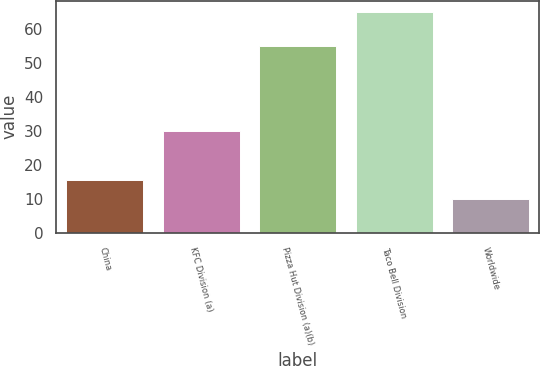<chart> <loc_0><loc_0><loc_500><loc_500><bar_chart><fcel>China<fcel>KFC Division (a)<fcel>Pizza Hut Division (a)(b)<fcel>Taco Bell Division<fcel>Worldwide<nl><fcel>15.5<fcel>30<fcel>55<fcel>65<fcel>10<nl></chart> 